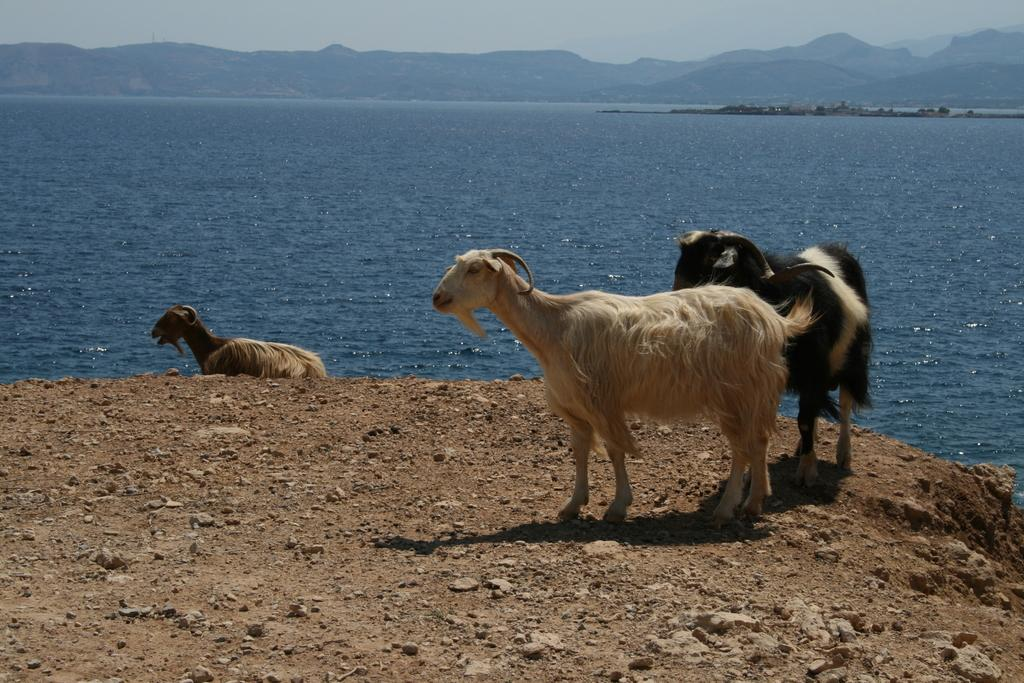What type of animals can be seen on the ground in the image? The specific type of animals cannot be determined from the provided facts, but there are animals on the ground in the image. What is the terrain like in the image? There is water visible in the image, which suggests that the terrain may include a body of water. What geographical features can be seen in the image? There are mountains in the image. What is visible at the top of the image? The sky is visible at the top of the image. What type of linen is being used to play volleyball in the image? There is no linen or volleyball present in the image. What cast members can be seen in the image? There is no reference to a cast or any actors in the image. 